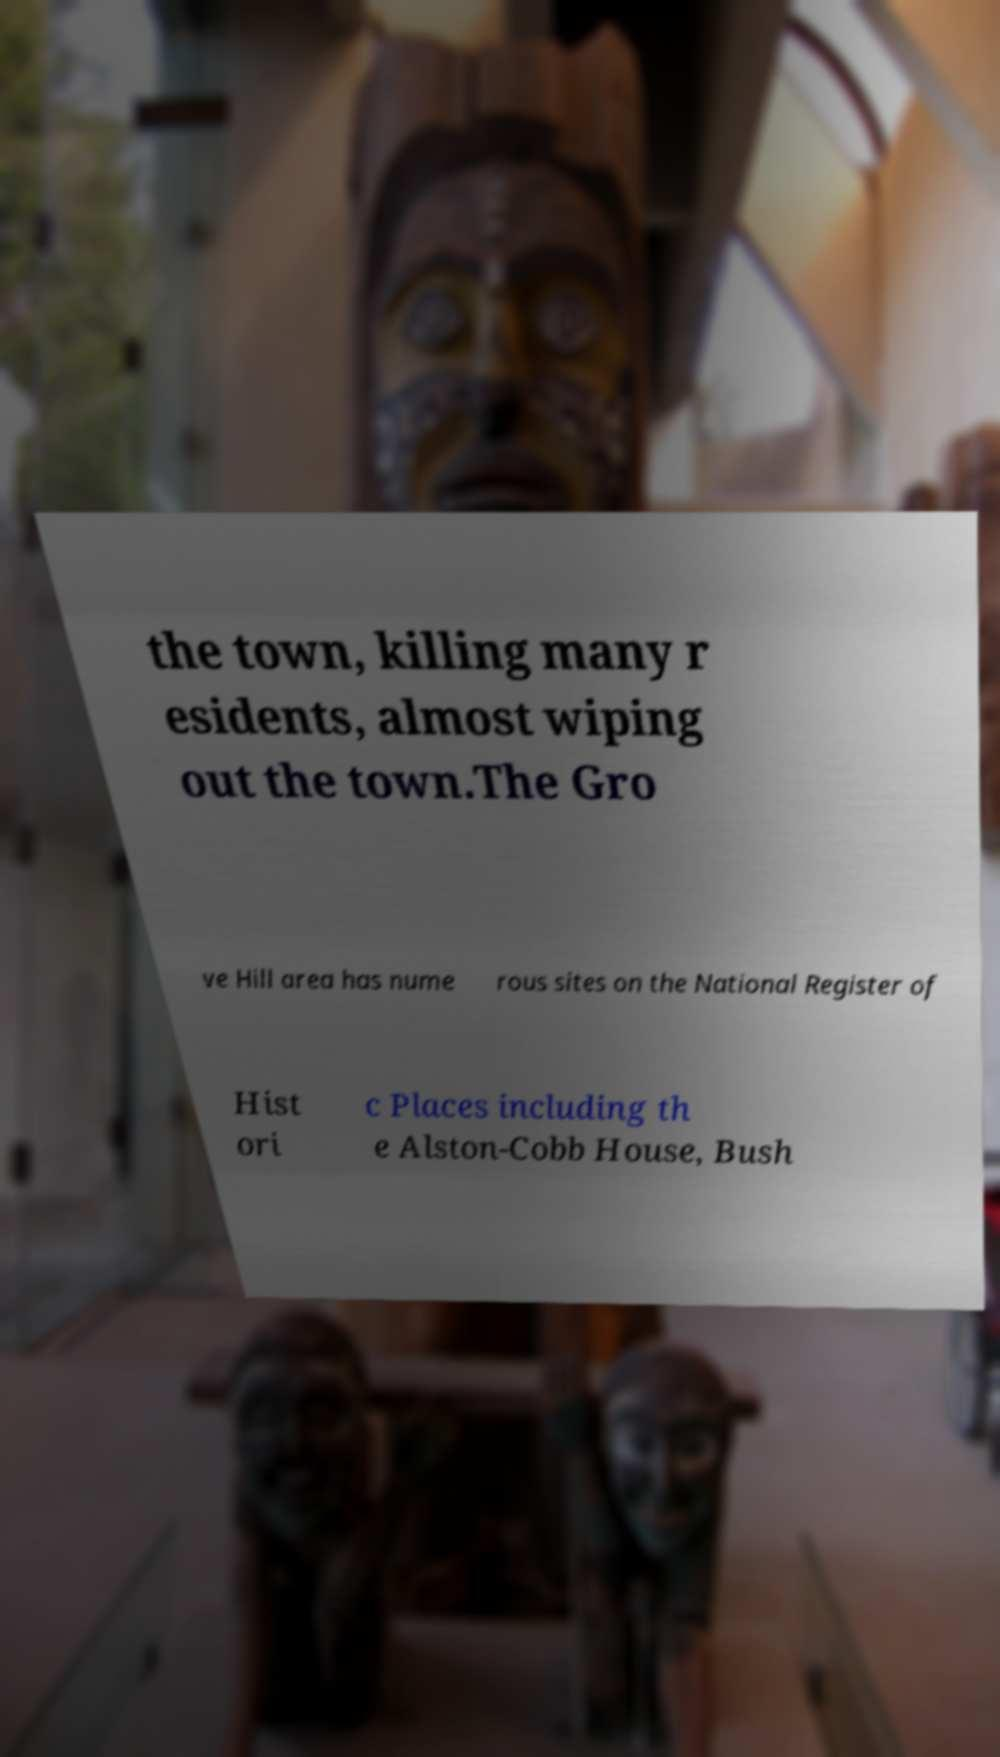Please read and relay the text visible in this image. What does it say? the town, killing many r esidents, almost wiping out the town.The Gro ve Hill area has nume rous sites on the National Register of Hist ori c Places including th e Alston-Cobb House, Bush 